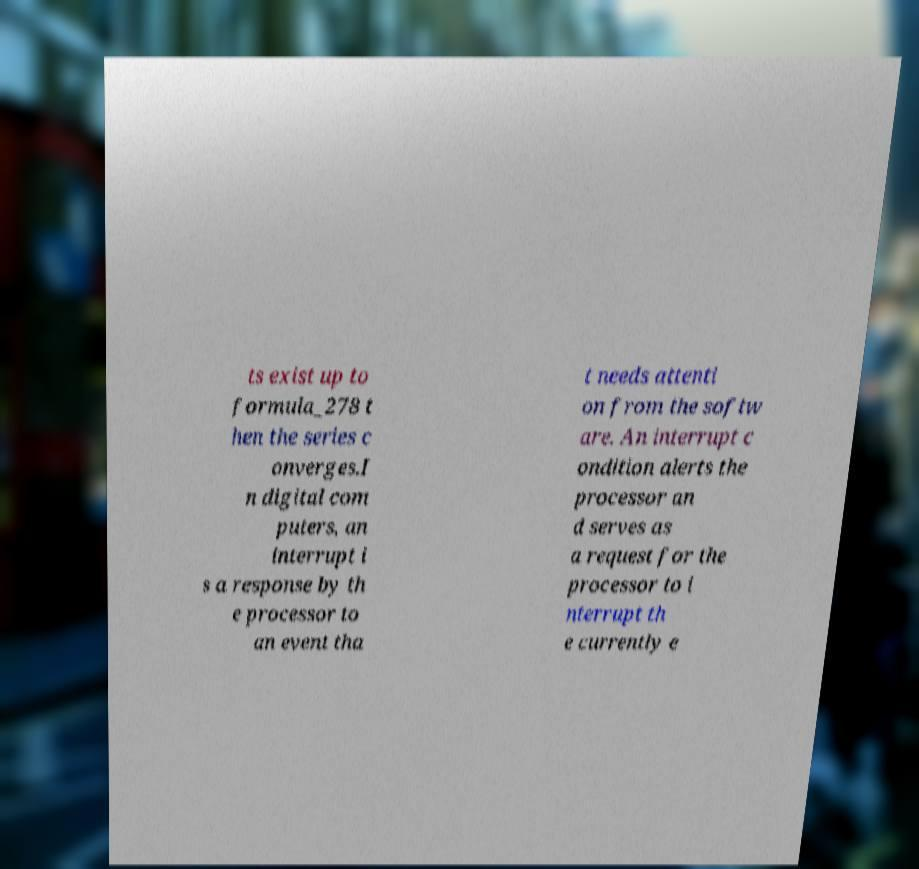Please read and relay the text visible in this image. What does it say? ts exist up to formula_278 t hen the series c onverges.I n digital com puters, an interrupt i s a response by th e processor to an event tha t needs attenti on from the softw are. An interrupt c ondition alerts the processor an d serves as a request for the processor to i nterrupt th e currently e 